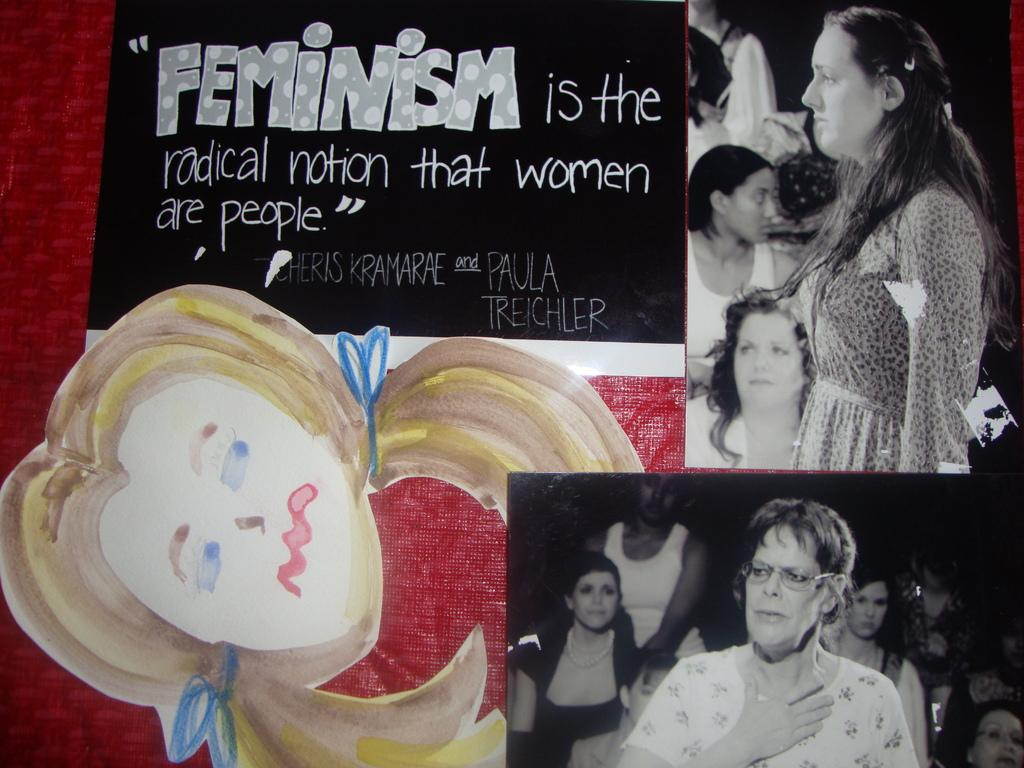How many photos can be seen in the image? There are two photos in the image. What else is present in the image besides the photos? There is a paper with a quotation and a paper cut in the shape of a girl's face in the image. How many houses are visible in the image? There are no houses visible in the image; it only contains photos, a paper with a quotation, and a paper cut in the shape of a girl's face. 